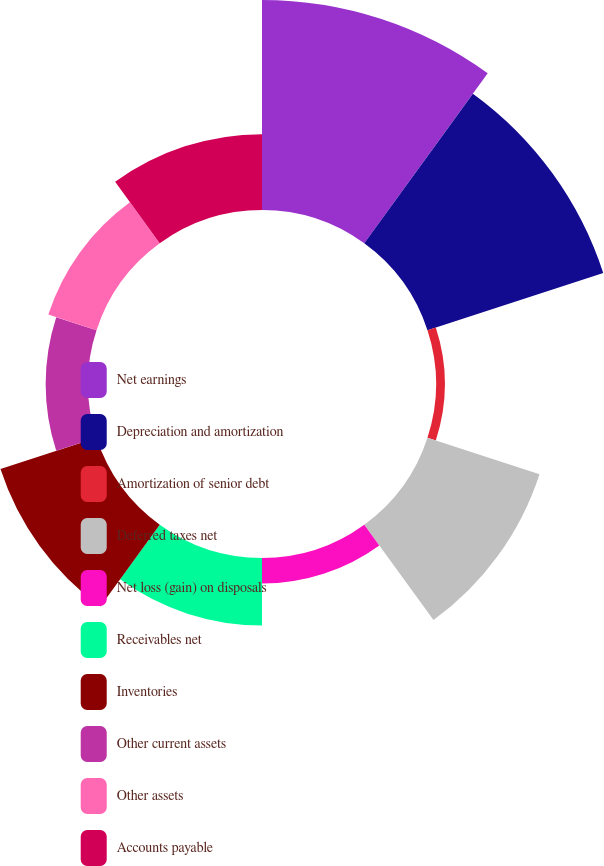Convert chart. <chart><loc_0><loc_0><loc_500><loc_500><pie_chart><fcel>Net earnings<fcel>Depreciation and amortization<fcel>Amortization of senior debt<fcel>Deferred taxes net<fcel>Net loss (gain) on disposals<fcel>Receivables net<fcel>Inventories<fcel>Other current assets<fcel>Other assets<fcel>Accounts payable<nl><fcel>23.75%<fcel>20.9%<fcel>0.99%<fcel>13.32%<fcel>2.89%<fcel>7.63%<fcel>11.42%<fcel>4.79%<fcel>5.73%<fcel>8.58%<nl></chart> 